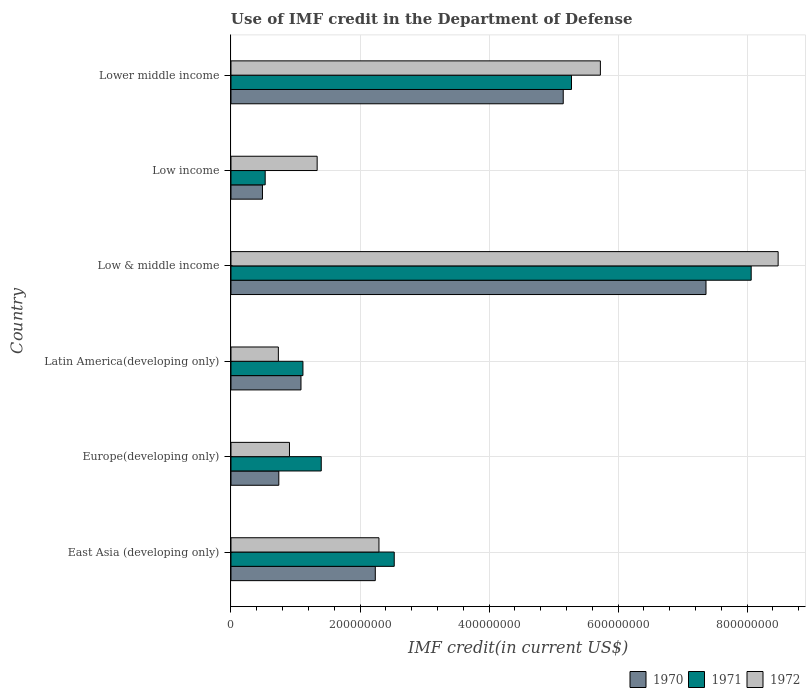How many different coloured bars are there?
Keep it short and to the point. 3. How many groups of bars are there?
Provide a short and direct response. 6. Are the number of bars per tick equal to the number of legend labels?
Make the answer very short. Yes. How many bars are there on the 1st tick from the top?
Provide a short and direct response. 3. What is the label of the 6th group of bars from the top?
Your response must be concise. East Asia (developing only). In how many cases, is the number of bars for a given country not equal to the number of legend labels?
Provide a short and direct response. 0. What is the IMF credit in the Department of Defense in 1970 in Low & middle income?
Make the answer very short. 7.36e+08. Across all countries, what is the maximum IMF credit in the Department of Defense in 1971?
Give a very brief answer. 8.06e+08. Across all countries, what is the minimum IMF credit in the Department of Defense in 1972?
Your answer should be compact. 7.34e+07. In which country was the IMF credit in the Department of Defense in 1972 minimum?
Provide a succinct answer. Latin America(developing only). What is the total IMF credit in the Department of Defense in 1970 in the graph?
Offer a terse response. 1.71e+09. What is the difference between the IMF credit in the Department of Defense in 1972 in Low & middle income and that in Lower middle income?
Keep it short and to the point. 2.76e+08. What is the difference between the IMF credit in the Department of Defense in 1972 in Europe(developing only) and the IMF credit in the Department of Defense in 1970 in Low income?
Your response must be concise. 4.18e+07. What is the average IMF credit in the Department of Defense in 1970 per country?
Offer a terse response. 2.84e+08. What is the difference between the IMF credit in the Department of Defense in 1970 and IMF credit in the Department of Defense in 1971 in Low & middle income?
Offer a terse response. -7.00e+07. What is the ratio of the IMF credit in the Department of Defense in 1972 in East Asia (developing only) to that in Latin America(developing only)?
Make the answer very short. 3.12. Is the IMF credit in the Department of Defense in 1970 in Low & middle income less than that in Lower middle income?
Your answer should be very brief. No. Is the difference between the IMF credit in the Department of Defense in 1970 in Europe(developing only) and Low & middle income greater than the difference between the IMF credit in the Department of Defense in 1971 in Europe(developing only) and Low & middle income?
Make the answer very short. Yes. What is the difference between the highest and the second highest IMF credit in the Department of Defense in 1971?
Provide a succinct answer. 2.79e+08. What is the difference between the highest and the lowest IMF credit in the Department of Defense in 1972?
Give a very brief answer. 7.75e+08. What does the 2nd bar from the bottom in Lower middle income represents?
Offer a very short reply. 1971. How many bars are there?
Offer a very short reply. 18. What is the difference between two consecutive major ticks on the X-axis?
Offer a terse response. 2.00e+08. Does the graph contain any zero values?
Keep it short and to the point. No. Does the graph contain grids?
Your answer should be compact. Yes. Where does the legend appear in the graph?
Keep it short and to the point. Bottom right. What is the title of the graph?
Offer a very short reply. Use of IMF credit in the Department of Defense. What is the label or title of the X-axis?
Offer a terse response. IMF credit(in current US$). What is the IMF credit(in current US$) in 1970 in East Asia (developing only)?
Keep it short and to the point. 2.24e+08. What is the IMF credit(in current US$) of 1971 in East Asia (developing only)?
Your answer should be compact. 2.53e+08. What is the IMF credit(in current US$) of 1972 in East Asia (developing only)?
Make the answer very short. 2.29e+08. What is the IMF credit(in current US$) of 1970 in Europe(developing only)?
Offer a terse response. 7.41e+07. What is the IMF credit(in current US$) in 1971 in Europe(developing only)?
Provide a succinct answer. 1.40e+08. What is the IMF credit(in current US$) in 1972 in Europe(developing only)?
Your response must be concise. 9.07e+07. What is the IMF credit(in current US$) of 1970 in Latin America(developing only)?
Make the answer very short. 1.09e+08. What is the IMF credit(in current US$) of 1971 in Latin America(developing only)?
Offer a terse response. 1.12e+08. What is the IMF credit(in current US$) in 1972 in Latin America(developing only)?
Your answer should be compact. 7.34e+07. What is the IMF credit(in current US$) of 1970 in Low & middle income?
Provide a succinct answer. 7.36e+08. What is the IMF credit(in current US$) in 1971 in Low & middle income?
Provide a succinct answer. 8.06e+08. What is the IMF credit(in current US$) in 1972 in Low & middle income?
Offer a very short reply. 8.48e+08. What is the IMF credit(in current US$) in 1970 in Low income?
Give a very brief answer. 4.88e+07. What is the IMF credit(in current US$) in 1971 in Low income?
Your answer should be compact. 5.30e+07. What is the IMF credit(in current US$) of 1972 in Low income?
Provide a succinct answer. 1.34e+08. What is the IMF credit(in current US$) of 1970 in Lower middle income?
Offer a terse response. 5.15e+08. What is the IMF credit(in current US$) of 1971 in Lower middle income?
Make the answer very short. 5.28e+08. What is the IMF credit(in current US$) of 1972 in Lower middle income?
Offer a very short reply. 5.73e+08. Across all countries, what is the maximum IMF credit(in current US$) in 1970?
Provide a succinct answer. 7.36e+08. Across all countries, what is the maximum IMF credit(in current US$) of 1971?
Provide a short and direct response. 8.06e+08. Across all countries, what is the maximum IMF credit(in current US$) of 1972?
Your answer should be very brief. 8.48e+08. Across all countries, what is the minimum IMF credit(in current US$) in 1970?
Ensure brevity in your answer.  4.88e+07. Across all countries, what is the minimum IMF credit(in current US$) of 1971?
Give a very brief answer. 5.30e+07. Across all countries, what is the minimum IMF credit(in current US$) of 1972?
Provide a short and direct response. 7.34e+07. What is the total IMF credit(in current US$) in 1970 in the graph?
Keep it short and to the point. 1.71e+09. What is the total IMF credit(in current US$) in 1971 in the graph?
Offer a very short reply. 1.89e+09. What is the total IMF credit(in current US$) of 1972 in the graph?
Ensure brevity in your answer.  1.95e+09. What is the difference between the IMF credit(in current US$) in 1970 in East Asia (developing only) and that in Europe(developing only)?
Your answer should be compact. 1.50e+08. What is the difference between the IMF credit(in current US$) in 1971 in East Asia (developing only) and that in Europe(developing only)?
Your answer should be very brief. 1.13e+08. What is the difference between the IMF credit(in current US$) in 1972 in East Asia (developing only) and that in Europe(developing only)?
Offer a very short reply. 1.39e+08. What is the difference between the IMF credit(in current US$) in 1970 in East Asia (developing only) and that in Latin America(developing only)?
Offer a terse response. 1.15e+08. What is the difference between the IMF credit(in current US$) in 1971 in East Asia (developing only) and that in Latin America(developing only)?
Provide a succinct answer. 1.42e+08. What is the difference between the IMF credit(in current US$) in 1972 in East Asia (developing only) and that in Latin America(developing only)?
Keep it short and to the point. 1.56e+08. What is the difference between the IMF credit(in current US$) in 1970 in East Asia (developing only) and that in Low & middle income?
Ensure brevity in your answer.  -5.13e+08. What is the difference between the IMF credit(in current US$) in 1971 in East Asia (developing only) and that in Low & middle income?
Your answer should be compact. -5.53e+08. What is the difference between the IMF credit(in current US$) in 1972 in East Asia (developing only) and that in Low & middle income?
Provide a succinct answer. -6.19e+08. What is the difference between the IMF credit(in current US$) in 1970 in East Asia (developing only) and that in Low income?
Provide a succinct answer. 1.75e+08. What is the difference between the IMF credit(in current US$) in 1971 in East Asia (developing only) and that in Low income?
Provide a short and direct response. 2.00e+08. What is the difference between the IMF credit(in current US$) in 1972 in East Asia (developing only) and that in Low income?
Provide a short and direct response. 9.58e+07. What is the difference between the IMF credit(in current US$) of 1970 in East Asia (developing only) and that in Lower middle income?
Make the answer very short. -2.91e+08. What is the difference between the IMF credit(in current US$) in 1971 in East Asia (developing only) and that in Lower middle income?
Provide a succinct answer. -2.75e+08. What is the difference between the IMF credit(in current US$) in 1972 in East Asia (developing only) and that in Lower middle income?
Keep it short and to the point. -3.43e+08. What is the difference between the IMF credit(in current US$) in 1970 in Europe(developing only) and that in Latin America(developing only)?
Make the answer very short. -3.44e+07. What is the difference between the IMF credit(in current US$) in 1971 in Europe(developing only) and that in Latin America(developing only)?
Provide a succinct answer. 2.84e+07. What is the difference between the IMF credit(in current US$) in 1972 in Europe(developing only) and that in Latin America(developing only)?
Provide a succinct answer. 1.72e+07. What is the difference between the IMF credit(in current US$) of 1970 in Europe(developing only) and that in Low & middle income?
Give a very brief answer. -6.62e+08. What is the difference between the IMF credit(in current US$) in 1971 in Europe(developing only) and that in Low & middle income?
Offer a very short reply. -6.66e+08. What is the difference between the IMF credit(in current US$) in 1972 in Europe(developing only) and that in Low & middle income?
Your answer should be compact. -7.57e+08. What is the difference between the IMF credit(in current US$) in 1970 in Europe(developing only) and that in Low income?
Offer a terse response. 2.53e+07. What is the difference between the IMF credit(in current US$) of 1971 in Europe(developing only) and that in Low income?
Your response must be concise. 8.69e+07. What is the difference between the IMF credit(in current US$) of 1972 in Europe(developing only) and that in Low income?
Make the answer very short. -4.29e+07. What is the difference between the IMF credit(in current US$) in 1970 in Europe(developing only) and that in Lower middle income?
Ensure brevity in your answer.  -4.41e+08. What is the difference between the IMF credit(in current US$) of 1971 in Europe(developing only) and that in Lower middle income?
Give a very brief answer. -3.88e+08. What is the difference between the IMF credit(in current US$) in 1972 in Europe(developing only) and that in Lower middle income?
Give a very brief answer. -4.82e+08. What is the difference between the IMF credit(in current US$) in 1970 in Latin America(developing only) and that in Low & middle income?
Ensure brevity in your answer.  -6.28e+08. What is the difference between the IMF credit(in current US$) in 1971 in Latin America(developing only) and that in Low & middle income?
Offer a terse response. -6.95e+08. What is the difference between the IMF credit(in current US$) of 1972 in Latin America(developing only) and that in Low & middle income?
Offer a terse response. -7.75e+08. What is the difference between the IMF credit(in current US$) of 1970 in Latin America(developing only) and that in Low income?
Your response must be concise. 5.97e+07. What is the difference between the IMF credit(in current US$) in 1971 in Latin America(developing only) and that in Low income?
Make the answer very short. 5.85e+07. What is the difference between the IMF credit(in current US$) of 1972 in Latin America(developing only) and that in Low income?
Offer a very short reply. -6.01e+07. What is the difference between the IMF credit(in current US$) in 1970 in Latin America(developing only) and that in Lower middle income?
Provide a succinct answer. -4.06e+08. What is the difference between the IMF credit(in current US$) in 1971 in Latin America(developing only) and that in Lower middle income?
Ensure brevity in your answer.  -4.16e+08. What is the difference between the IMF credit(in current US$) in 1972 in Latin America(developing only) and that in Lower middle income?
Make the answer very short. -4.99e+08. What is the difference between the IMF credit(in current US$) in 1970 in Low & middle income and that in Low income?
Provide a short and direct response. 6.87e+08. What is the difference between the IMF credit(in current US$) in 1971 in Low & middle income and that in Low income?
Provide a succinct answer. 7.53e+08. What is the difference between the IMF credit(in current US$) of 1972 in Low & middle income and that in Low income?
Your answer should be compact. 7.14e+08. What is the difference between the IMF credit(in current US$) in 1970 in Low & middle income and that in Lower middle income?
Offer a very short reply. 2.21e+08. What is the difference between the IMF credit(in current US$) of 1971 in Low & middle income and that in Lower middle income?
Give a very brief answer. 2.79e+08. What is the difference between the IMF credit(in current US$) in 1972 in Low & middle income and that in Lower middle income?
Your answer should be compact. 2.76e+08. What is the difference between the IMF credit(in current US$) in 1970 in Low income and that in Lower middle income?
Your answer should be very brief. -4.66e+08. What is the difference between the IMF credit(in current US$) of 1971 in Low income and that in Lower middle income?
Your response must be concise. -4.75e+08. What is the difference between the IMF credit(in current US$) of 1972 in Low income and that in Lower middle income?
Offer a terse response. -4.39e+08. What is the difference between the IMF credit(in current US$) in 1970 in East Asia (developing only) and the IMF credit(in current US$) in 1971 in Europe(developing only)?
Provide a succinct answer. 8.38e+07. What is the difference between the IMF credit(in current US$) in 1970 in East Asia (developing only) and the IMF credit(in current US$) in 1972 in Europe(developing only)?
Provide a succinct answer. 1.33e+08. What is the difference between the IMF credit(in current US$) in 1971 in East Asia (developing only) and the IMF credit(in current US$) in 1972 in Europe(developing only)?
Provide a short and direct response. 1.62e+08. What is the difference between the IMF credit(in current US$) of 1970 in East Asia (developing only) and the IMF credit(in current US$) of 1971 in Latin America(developing only)?
Make the answer very short. 1.12e+08. What is the difference between the IMF credit(in current US$) in 1970 in East Asia (developing only) and the IMF credit(in current US$) in 1972 in Latin America(developing only)?
Keep it short and to the point. 1.50e+08. What is the difference between the IMF credit(in current US$) of 1971 in East Asia (developing only) and the IMF credit(in current US$) of 1972 in Latin America(developing only)?
Your answer should be very brief. 1.80e+08. What is the difference between the IMF credit(in current US$) in 1970 in East Asia (developing only) and the IMF credit(in current US$) in 1971 in Low & middle income?
Offer a very short reply. -5.83e+08. What is the difference between the IMF credit(in current US$) of 1970 in East Asia (developing only) and the IMF credit(in current US$) of 1972 in Low & middle income?
Make the answer very short. -6.24e+08. What is the difference between the IMF credit(in current US$) in 1971 in East Asia (developing only) and the IMF credit(in current US$) in 1972 in Low & middle income?
Give a very brief answer. -5.95e+08. What is the difference between the IMF credit(in current US$) in 1970 in East Asia (developing only) and the IMF credit(in current US$) in 1971 in Low income?
Ensure brevity in your answer.  1.71e+08. What is the difference between the IMF credit(in current US$) in 1970 in East Asia (developing only) and the IMF credit(in current US$) in 1972 in Low income?
Your answer should be compact. 9.01e+07. What is the difference between the IMF credit(in current US$) in 1971 in East Asia (developing only) and the IMF credit(in current US$) in 1972 in Low income?
Offer a terse response. 1.19e+08. What is the difference between the IMF credit(in current US$) of 1970 in East Asia (developing only) and the IMF credit(in current US$) of 1971 in Lower middle income?
Keep it short and to the point. -3.04e+08. What is the difference between the IMF credit(in current US$) in 1970 in East Asia (developing only) and the IMF credit(in current US$) in 1972 in Lower middle income?
Your response must be concise. -3.49e+08. What is the difference between the IMF credit(in current US$) in 1971 in East Asia (developing only) and the IMF credit(in current US$) in 1972 in Lower middle income?
Give a very brief answer. -3.20e+08. What is the difference between the IMF credit(in current US$) of 1970 in Europe(developing only) and the IMF credit(in current US$) of 1971 in Latin America(developing only)?
Your answer should be compact. -3.74e+07. What is the difference between the IMF credit(in current US$) in 1970 in Europe(developing only) and the IMF credit(in current US$) in 1972 in Latin America(developing only)?
Give a very brief answer. 7.05e+05. What is the difference between the IMF credit(in current US$) of 1971 in Europe(developing only) and the IMF credit(in current US$) of 1972 in Latin America(developing only)?
Give a very brief answer. 6.65e+07. What is the difference between the IMF credit(in current US$) of 1970 in Europe(developing only) and the IMF credit(in current US$) of 1971 in Low & middle income?
Your answer should be compact. -7.32e+08. What is the difference between the IMF credit(in current US$) of 1970 in Europe(developing only) and the IMF credit(in current US$) of 1972 in Low & middle income?
Offer a very short reply. -7.74e+08. What is the difference between the IMF credit(in current US$) in 1971 in Europe(developing only) and the IMF credit(in current US$) in 1972 in Low & middle income?
Provide a succinct answer. -7.08e+08. What is the difference between the IMF credit(in current US$) of 1970 in Europe(developing only) and the IMF credit(in current US$) of 1971 in Low income?
Offer a terse response. 2.11e+07. What is the difference between the IMF credit(in current US$) in 1970 in Europe(developing only) and the IMF credit(in current US$) in 1972 in Low income?
Keep it short and to the point. -5.94e+07. What is the difference between the IMF credit(in current US$) of 1971 in Europe(developing only) and the IMF credit(in current US$) of 1972 in Low income?
Provide a short and direct response. 6.35e+06. What is the difference between the IMF credit(in current US$) in 1970 in Europe(developing only) and the IMF credit(in current US$) in 1971 in Lower middle income?
Your answer should be compact. -4.54e+08. What is the difference between the IMF credit(in current US$) in 1970 in Europe(developing only) and the IMF credit(in current US$) in 1972 in Lower middle income?
Give a very brief answer. -4.98e+08. What is the difference between the IMF credit(in current US$) in 1971 in Europe(developing only) and the IMF credit(in current US$) in 1972 in Lower middle income?
Provide a succinct answer. -4.33e+08. What is the difference between the IMF credit(in current US$) of 1970 in Latin America(developing only) and the IMF credit(in current US$) of 1971 in Low & middle income?
Keep it short and to the point. -6.98e+08. What is the difference between the IMF credit(in current US$) in 1970 in Latin America(developing only) and the IMF credit(in current US$) in 1972 in Low & middle income?
Provide a short and direct response. -7.40e+08. What is the difference between the IMF credit(in current US$) of 1971 in Latin America(developing only) and the IMF credit(in current US$) of 1972 in Low & middle income?
Provide a succinct answer. -7.37e+08. What is the difference between the IMF credit(in current US$) of 1970 in Latin America(developing only) and the IMF credit(in current US$) of 1971 in Low income?
Keep it short and to the point. 5.55e+07. What is the difference between the IMF credit(in current US$) of 1970 in Latin America(developing only) and the IMF credit(in current US$) of 1972 in Low income?
Make the answer very short. -2.50e+07. What is the difference between the IMF credit(in current US$) of 1971 in Latin America(developing only) and the IMF credit(in current US$) of 1972 in Low income?
Ensure brevity in your answer.  -2.20e+07. What is the difference between the IMF credit(in current US$) of 1970 in Latin America(developing only) and the IMF credit(in current US$) of 1971 in Lower middle income?
Offer a very short reply. -4.19e+08. What is the difference between the IMF credit(in current US$) of 1970 in Latin America(developing only) and the IMF credit(in current US$) of 1972 in Lower middle income?
Keep it short and to the point. -4.64e+08. What is the difference between the IMF credit(in current US$) of 1971 in Latin America(developing only) and the IMF credit(in current US$) of 1972 in Lower middle income?
Provide a short and direct response. -4.61e+08. What is the difference between the IMF credit(in current US$) in 1970 in Low & middle income and the IMF credit(in current US$) in 1971 in Low income?
Offer a very short reply. 6.83e+08. What is the difference between the IMF credit(in current US$) of 1970 in Low & middle income and the IMF credit(in current US$) of 1972 in Low income?
Make the answer very short. 6.03e+08. What is the difference between the IMF credit(in current US$) in 1971 in Low & middle income and the IMF credit(in current US$) in 1972 in Low income?
Give a very brief answer. 6.73e+08. What is the difference between the IMF credit(in current US$) of 1970 in Low & middle income and the IMF credit(in current US$) of 1971 in Lower middle income?
Your answer should be very brief. 2.08e+08. What is the difference between the IMF credit(in current US$) in 1970 in Low & middle income and the IMF credit(in current US$) in 1972 in Lower middle income?
Make the answer very short. 1.64e+08. What is the difference between the IMF credit(in current US$) in 1971 in Low & middle income and the IMF credit(in current US$) in 1972 in Lower middle income?
Offer a very short reply. 2.34e+08. What is the difference between the IMF credit(in current US$) of 1970 in Low income and the IMF credit(in current US$) of 1971 in Lower middle income?
Keep it short and to the point. -4.79e+08. What is the difference between the IMF credit(in current US$) of 1970 in Low income and the IMF credit(in current US$) of 1972 in Lower middle income?
Ensure brevity in your answer.  -5.24e+08. What is the difference between the IMF credit(in current US$) of 1971 in Low income and the IMF credit(in current US$) of 1972 in Lower middle income?
Provide a succinct answer. -5.20e+08. What is the average IMF credit(in current US$) of 1970 per country?
Your response must be concise. 2.84e+08. What is the average IMF credit(in current US$) of 1971 per country?
Ensure brevity in your answer.  3.15e+08. What is the average IMF credit(in current US$) of 1972 per country?
Provide a short and direct response. 3.25e+08. What is the difference between the IMF credit(in current US$) of 1970 and IMF credit(in current US$) of 1971 in East Asia (developing only)?
Keep it short and to the point. -2.93e+07. What is the difference between the IMF credit(in current US$) of 1970 and IMF credit(in current US$) of 1972 in East Asia (developing only)?
Your answer should be compact. -5.66e+06. What is the difference between the IMF credit(in current US$) in 1971 and IMF credit(in current US$) in 1972 in East Asia (developing only)?
Provide a short and direct response. 2.37e+07. What is the difference between the IMF credit(in current US$) in 1970 and IMF credit(in current US$) in 1971 in Europe(developing only)?
Ensure brevity in your answer.  -6.58e+07. What is the difference between the IMF credit(in current US$) in 1970 and IMF credit(in current US$) in 1972 in Europe(developing only)?
Ensure brevity in your answer.  -1.65e+07. What is the difference between the IMF credit(in current US$) in 1971 and IMF credit(in current US$) in 1972 in Europe(developing only)?
Offer a very short reply. 4.93e+07. What is the difference between the IMF credit(in current US$) in 1970 and IMF credit(in current US$) in 1971 in Latin America(developing only)?
Your answer should be compact. -3.01e+06. What is the difference between the IMF credit(in current US$) in 1970 and IMF credit(in current US$) in 1972 in Latin America(developing only)?
Offer a very short reply. 3.51e+07. What is the difference between the IMF credit(in current US$) in 1971 and IMF credit(in current US$) in 1972 in Latin America(developing only)?
Provide a succinct answer. 3.81e+07. What is the difference between the IMF credit(in current US$) in 1970 and IMF credit(in current US$) in 1971 in Low & middle income?
Offer a very short reply. -7.00e+07. What is the difference between the IMF credit(in current US$) of 1970 and IMF credit(in current US$) of 1972 in Low & middle income?
Keep it short and to the point. -1.12e+08. What is the difference between the IMF credit(in current US$) in 1971 and IMF credit(in current US$) in 1972 in Low & middle income?
Provide a succinct answer. -4.18e+07. What is the difference between the IMF credit(in current US$) of 1970 and IMF credit(in current US$) of 1971 in Low income?
Offer a very short reply. -4.21e+06. What is the difference between the IMF credit(in current US$) of 1970 and IMF credit(in current US$) of 1972 in Low income?
Keep it short and to the point. -8.47e+07. What is the difference between the IMF credit(in current US$) in 1971 and IMF credit(in current US$) in 1972 in Low income?
Your answer should be very brief. -8.05e+07. What is the difference between the IMF credit(in current US$) of 1970 and IMF credit(in current US$) of 1971 in Lower middle income?
Provide a succinct answer. -1.28e+07. What is the difference between the IMF credit(in current US$) of 1970 and IMF credit(in current US$) of 1972 in Lower middle income?
Provide a short and direct response. -5.76e+07. What is the difference between the IMF credit(in current US$) in 1971 and IMF credit(in current US$) in 1972 in Lower middle income?
Offer a terse response. -4.48e+07. What is the ratio of the IMF credit(in current US$) of 1970 in East Asia (developing only) to that in Europe(developing only)?
Your response must be concise. 3.02. What is the ratio of the IMF credit(in current US$) in 1971 in East Asia (developing only) to that in Europe(developing only)?
Your response must be concise. 1.81. What is the ratio of the IMF credit(in current US$) of 1972 in East Asia (developing only) to that in Europe(developing only)?
Provide a succinct answer. 2.53. What is the ratio of the IMF credit(in current US$) of 1970 in East Asia (developing only) to that in Latin America(developing only)?
Give a very brief answer. 2.06. What is the ratio of the IMF credit(in current US$) in 1971 in East Asia (developing only) to that in Latin America(developing only)?
Provide a succinct answer. 2.27. What is the ratio of the IMF credit(in current US$) of 1972 in East Asia (developing only) to that in Latin America(developing only)?
Offer a very short reply. 3.12. What is the ratio of the IMF credit(in current US$) in 1970 in East Asia (developing only) to that in Low & middle income?
Provide a succinct answer. 0.3. What is the ratio of the IMF credit(in current US$) of 1971 in East Asia (developing only) to that in Low & middle income?
Keep it short and to the point. 0.31. What is the ratio of the IMF credit(in current US$) of 1972 in East Asia (developing only) to that in Low & middle income?
Ensure brevity in your answer.  0.27. What is the ratio of the IMF credit(in current US$) in 1970 in East Asia (developing only) to that in Low income?
Offer a very short reply. 4.58. What is the ratio of the IMF credit(in current US$) in 1971 in East Asia (developing only) to that in Low income?
Your answer should be very brief. 4.77. What is the ratio of the IMF credit(in current US$) of 1972 in East Asia (developing only) to that in Low income?
Offer a very short reply. 1.72. What is the ratio of the IMF credit(in current US$) in 1970 in East Asia (developing only) to that in Lower middle income?
Provide a short and direct response. 0.43. What is the ratio of the IMF credit(in current US$) in 1971 in East Asia (developing only) to that in Lower middle income?
Offer a very short reply. 0.48. What is the ratio of the IMF credit(in current US$) in 1972 in East Asia (developing only) to that in Lower middle income?
Ensure brevity in your answer.  0.4. What is the ratio of the IMF credit(in current US$) of 1970 in Europe(developing only) to that in Latin America(developing only)?
Your response must be concise. 0.68. What is the ratio of the IMF credit(in current US$) of 1971 in Europe(developing only) to that in Latin America(developing only)?
Offer a terse response. 1.25. What is the ratio of the IMF credit(in current US$) in 1972 in Europe(developing only) to that in Latin America(developing only)?
Give a very brief answer. 1.23. What is the ratio of the IMF credit(in current US$) in 1970 in Europe(developing only) to that in Low & middle income?
Keep it short and to the point. 0.1. What is the ratio of the IMF credit(in current US$) of 1971 in Europe(developing only) to that in Low & middle income?
Provide a short and direct response. 0.17. What is the ratio of the IMF credit(in current US$) in 1972 in Europe(developing only) to that in Low & middle income?
Offer a terse response. 0.11. What is the ratio of the IMF credit(in current US$) of 1970 in Europe(developing only) to that in Low income?
Provide a succinct answer. 1.52. What is the ratio of the IMF credit(in current US$) in 1971 in Europe(developing only) to that in Low income?
Give a very brief answer. 2.64. What is the ratio of the IMF credit(in current US$) in 1972 in Europe(developing only) to that in Low income?
Keep it short and to the point. 0.68. What is the ratio of the IMF credit(in current US$) of 1970 in Europe(developing only) to that in Lower middle income?
Make the answer very short. 0.14. What is the ratio of the IMF credit(in current US$) of 1971 in Europe(developing only) to that in Lower middle income?
Your answer should be compact. 0.27. What is the ratio of the IMF credit(in current US$) in 1972 in Europe(developing only) to that in Lower middle income?
Your answer should be very brief. 0.16. What is the ratio of the IMF credit(in current US$) of 1970 in Latin America(developing only) to that in Low & middle income?
Ensure brevity in your answer.  0.15. What is the ratio of the IMF credit(in current US$) of 1971 in Latin America(developing only) to that in Low & middle income?
Your response must be concise. 0.14. What is the ratio of the IMF credit(in current US$) of 1972 in Latin America(developing only) to that in Low & middle income?
Provide a succinct answer. 0.09. What is the ratio of the IMF credit(in current US$) of 1970 in Latin America(developing only) to that in Low income?
Your answer should be compact. 2.22. What is the ratio of the IMF credit(in current US$) in 1971 in Latin America(developing only) to that in Low income?
Offer a terse response. 2.1. What is the ratio of the IMF credit(in current US$) in 1972 in Latin America(developing only) to that in Low income?
Give a very brief answer. 0.55. What is the ratio of the IMF credit(in current US$) of 1970 in Latin America(developing only) to that in Lower middle income?
Ensure brevity in your answer.  0.21. What is the ratio of the IMF credit(in current US$) of 1971 in Latin America(developing only) to that in Lower middle income?
Your answer should be very brief. 0.21. What is the ratio of the IMF credit(in current US$) of 1972 in Latin America(developing only) to that in Lower middle income?
Provide a short and direct response. 0.13. What is the ratio of the IMF credit(in current US$) of 1970 in Low & middle income to that in Low income?
Your answer should be compact. 15.08. What is the ratio of the IMF credit(in current US$) of 1971 in Low & middle income to that in Low income?
Ensure brevity in your answer.  15.21. What is the ratio of the IMF credit(in current US$) in 1972 in Low & middle income to that in Low income?
Your response must be concise. 6.35. What is the ratio of the IMF credit(in current US$) of 1970 in Low & middle income to that in Lower middle income?
Offer a terse response. 1.43. What is the ratio of the IMF credit(in current US$) in 1971 in Low & middle income to that in Lower middle income?
Offer a terse response. 1.53. What is the ratio of the IMF credit(in current US$) in 1972 in Low & middle income to that in Lower middle income?
Make the answer very short. 1.48. What is the ratio of the IMF credit(in current US$) of 1970 in Low income to that in Lower middle income?
Make the answer very short. 0.09. What is the ratio of the IMF credit(in current US$) in 1971 in Low income to that in Lower middle income?
Keep it short and to the point. 0.1. What is the ratio of the IMF credit(in current US$) of 1972 in Low income to that in Lower middle income?
Offer a very short reply. 0.23. What is the difference between the highest and the second highest IMF credit(in current US$) of 1970?
Provide a succinct answer. 2.21e+08. What is the difference between the highest and the second highest IMF credit(in current US$) in 1971?
Your answer should be very brief. 2.79e+08. What is the difference between the highest and the second highest IMF credit(in current US$) of 1972?
Provide a short and direct response. 2.76e+08. What is the difference between the highest and the lowest IMF credit(in current US$) of 1970?
Your answer should be compact. 6.87e+08. What is the difference between the highest and the lowest IMF credit(in current US$) in 1971?
Your response must be concise. 7.53e+08. What is the difference between the highest and the lowest IMF credit(in current US$) of 1972?
Give a very brief answer. 7.75e+08. 